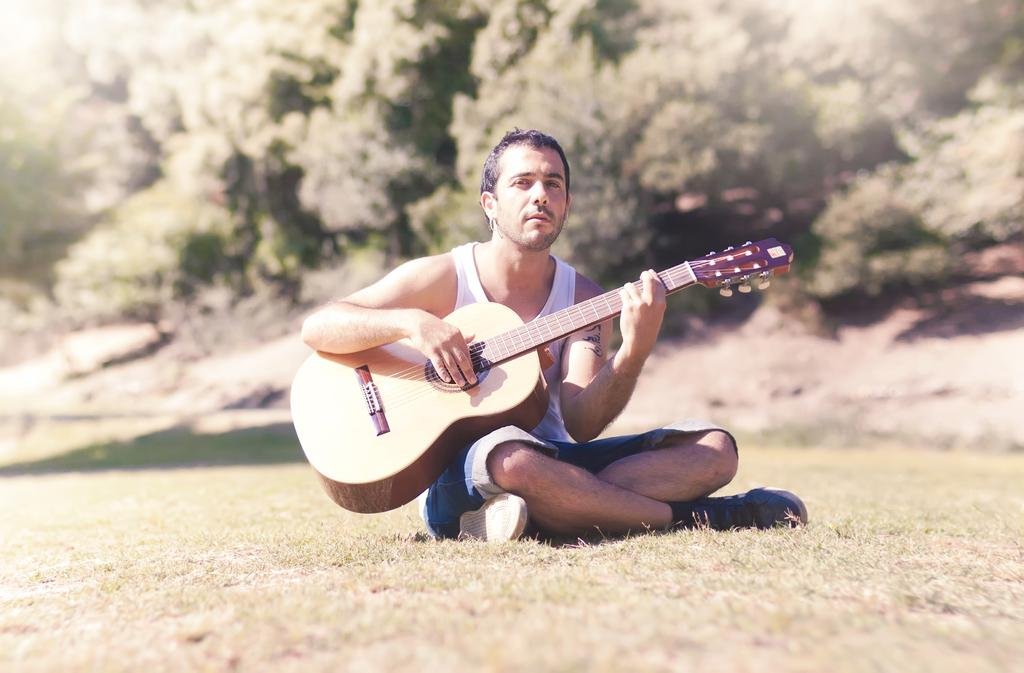What is the person in the image doing? The person is sitting on the ground. What is the person holding in the image? The person is holding a guitar. What can be seen in the background of the image? There are trees visible in the background. What type of punishment is being administered to the person in the image? There is no indication of punishment in the image; the person is simply sitting on the ground holding a guitar. 